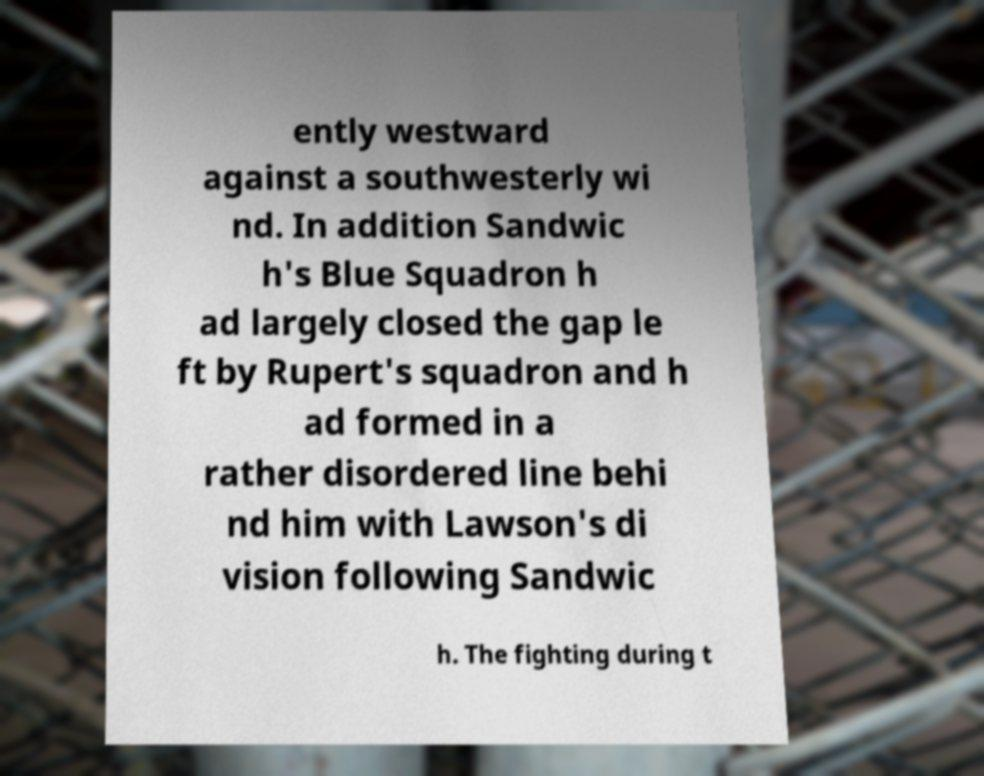Please read and relay the text visible in this image. What does it say? ently westward against a southwesterly wi nd. In addition Sandwic h's Blue Squadron h ad largely closed the gap le ft by Rupert's squadron and h ad formed in a rather disordered line behi nd him with Lawson's di vision following Sandwic h. The fighting during t 